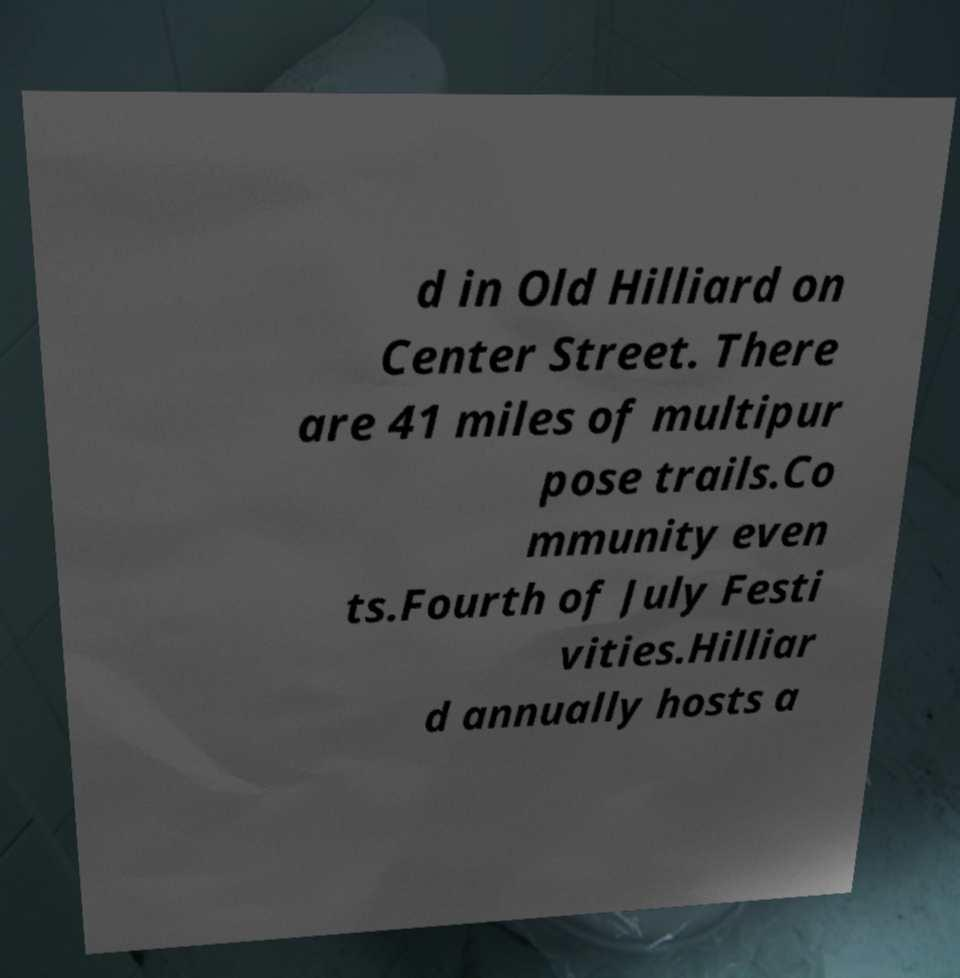There's text embedded in this image that I need extracted. Can you transcribe it verbatim? d in Old Hilliard on Center Street. There are 41 miles of multipur pose trails.Co mmunity even ts.Fourth of July Festi vities.Hilliar d annually hosts a 